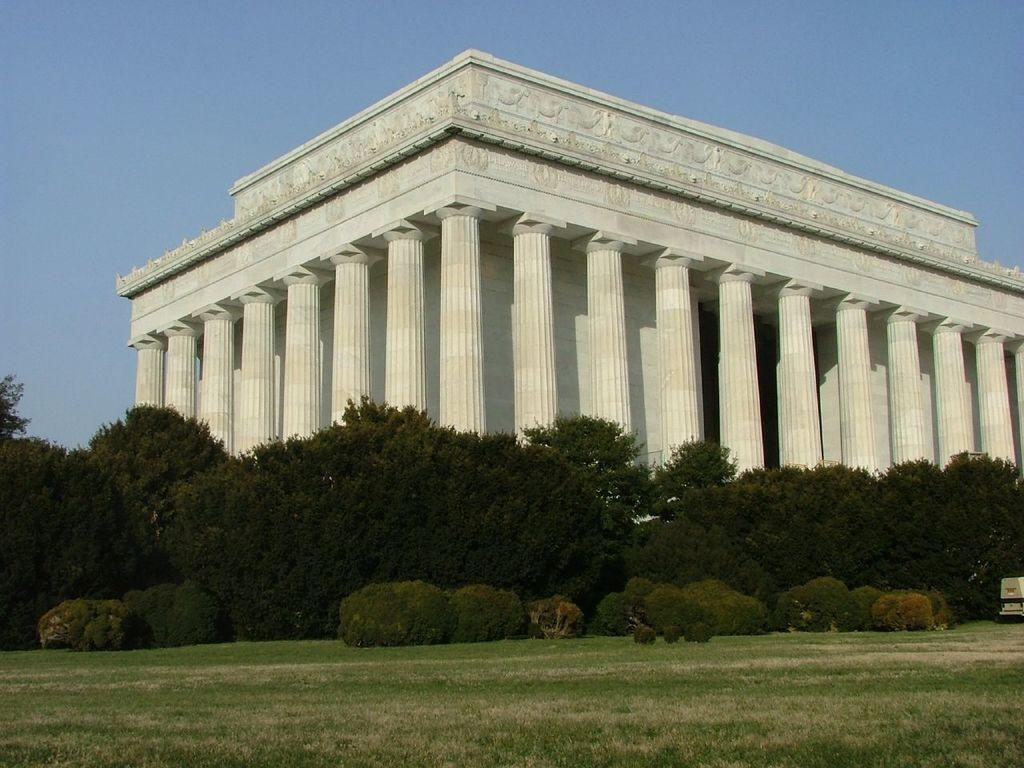What type of structure is visible in the image? There is a building in the image. What can be seen in the middle of the image? There are trees and plants in the middle of the image. What covers the ground in the image? There is grass on the ground. What is visible in the background of the image? The sky is visible in the background of the image. What type of rod is used to cook the beef in the image? There is no rod or beef present in the image; it features a building, trees and plants, grass, and the sky. 